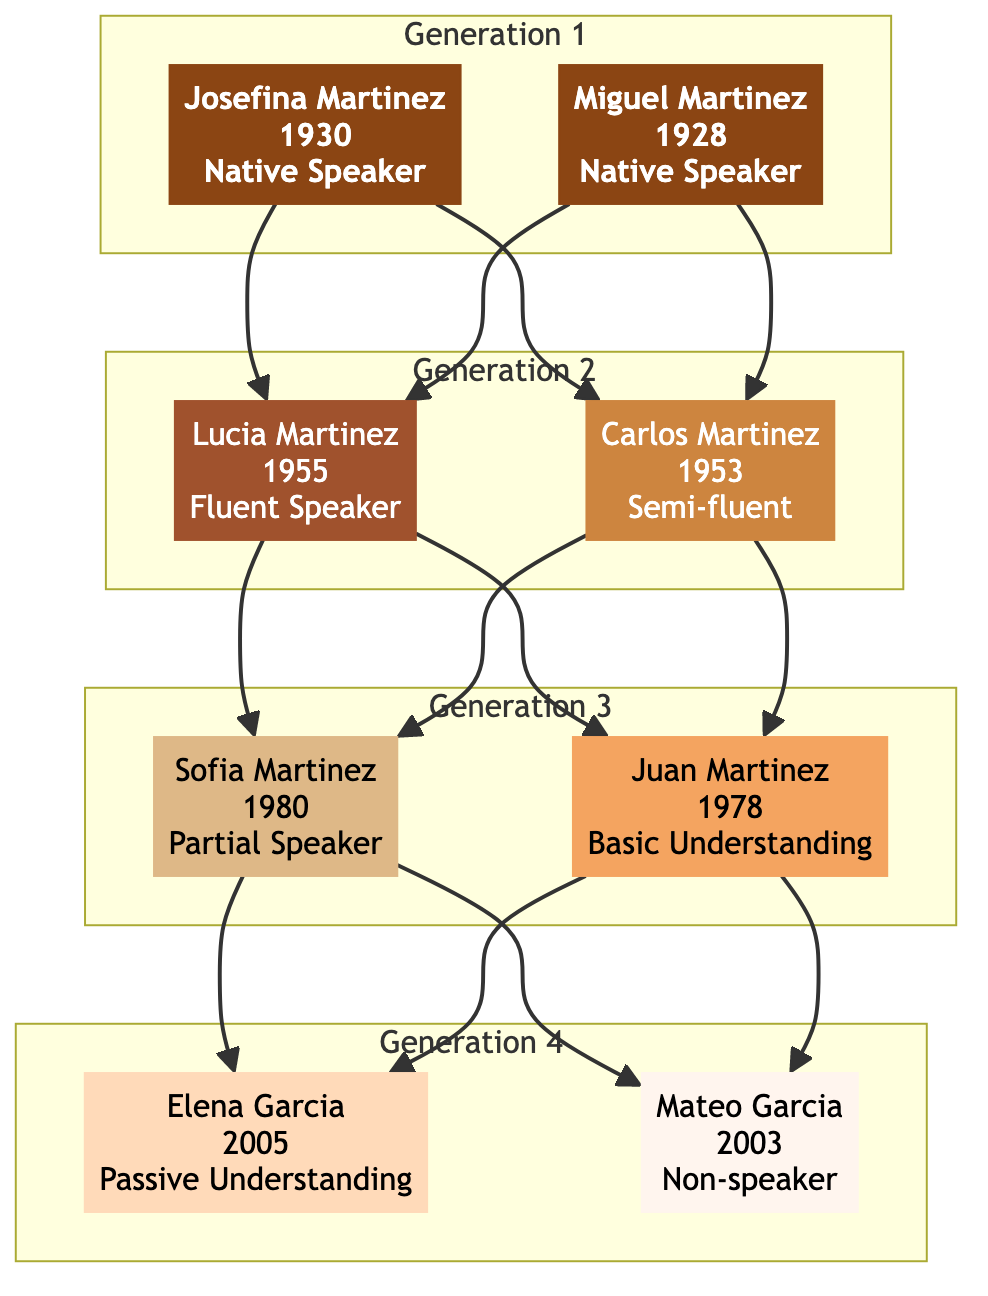What is the language proficiency of Josefina Martinez? The diagram indicates that Josefina Martinez is a "Native Speaker," which is stated directly under her node.
Answer: Native Speaker How many members are in Generation 3? By counting the nodes under the Generation 3 subgraph, we find there are two members: Sofia Martinez and Juan Martinez.
Answer: 2 What is the language usage of Carlos Martinez? The diagram mentions that Carlos Martinez utilizes the minority language for "Home conversations, limited social use." This information is located directly under his node.
Answer: Home conversations, limited social use Which member of Generation 4 has a passive understanding of the language? In the Generation 4 subgraph, Elena Garcia is identified as having "Passive Understanding," which is noted directly in her node.
Answer: Elena Garcia Who passed down the language through folklore and songs? The comment attached to Josefina Martinez mentions that she "passed down the language through folklore and songs," making this the answer to the question about who performed this action.
Answer: Josefina Martinez What was Juan Martinez's language proficiency? The diagram specifies that Juan Martinez has "Basic Understanding," which is shown directly in his node.
Answer: Basic Understanding Which generation has a non-speaker? Upon examining the diagram, we see that Mateo Garcia from Generation 4 is labeled as a "Non-speaker," identifying him as the member fitting this description.
Answer: Generation 4 What language proficiency did Lucia Martinez achieve? The node for Lucia Martinez indicates that she is a "Fluent Speaker," clearly stating her proficiency level.
Answer: Fluent Speaker What is the relationship between Lucia and Josefina Martinez? The diagram shows that Lucia Martinez is the child of Josefina Martinez, as she is in the second generation, and Josefina is in the first generation, connected by an arrow.
Answer: Mother-Daughter 